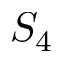Convert formula to latex. <formula><loc_0><loc_0><loc_500><loc_500>S _ { 4 }</formula> 